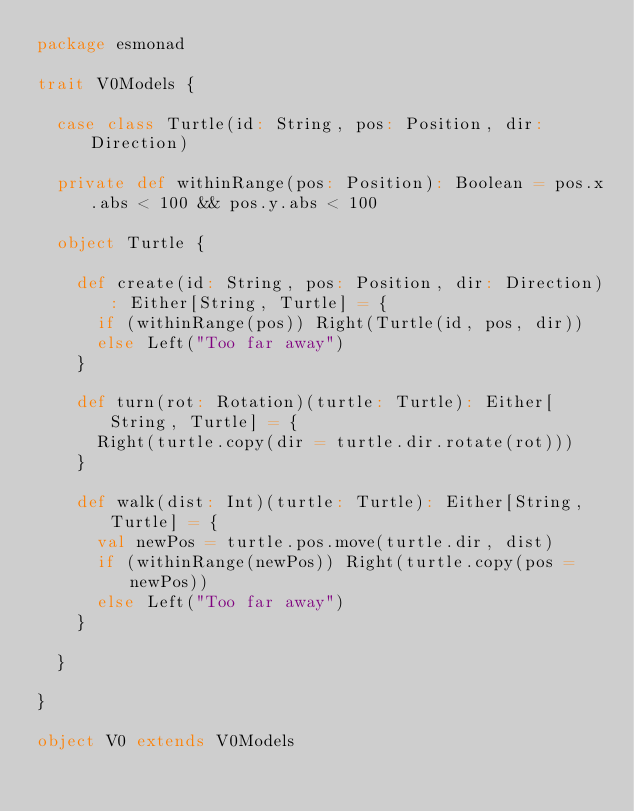Convert code to text. <code><loc_0><loc_0><loc_500><loc_500><_Scala_>package esmonad

trait V0Models {

  case class Turtle(id: String, pos: Position, dir: Direction)

  private def withinRange(pos: Position): Boolean = pos.x.abs < 100 && pos.y.abs < 100

  object Turtle {

    def create(id: String, pos: Position, dir: Direction): Either[String, Turtle] = {
      if (withinRange(pos)) Right(Turtle(id, pos, dir))
      else Left("Too far away")
    }

    def turn(rot: Rotation)(turtle: Turtle): Either[String, Turtle] = {
      Right(turtle.copy(dir = turtle.dir.rotate(rot)))
    }

    def walk(dist: Int)(turtle: Turtle): Either[String, Turtle] = {
      val newPos = turtle.pos.move(turtle.dir, dist)
      if (withinRange(newPos)) Right(turtle.copy(pos = newPos))
      else Left("Too far away")
    }

  }

}

object V0 extends V0Models
</code> 